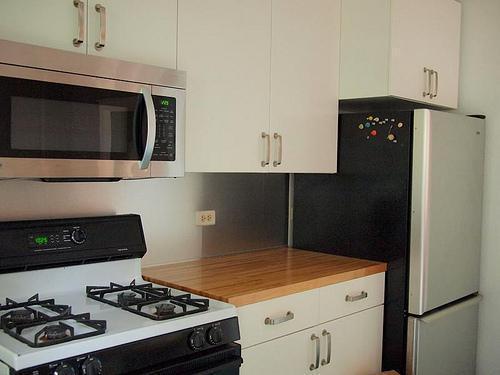How many cabinets are there?
Give a very brief answer. 8. 